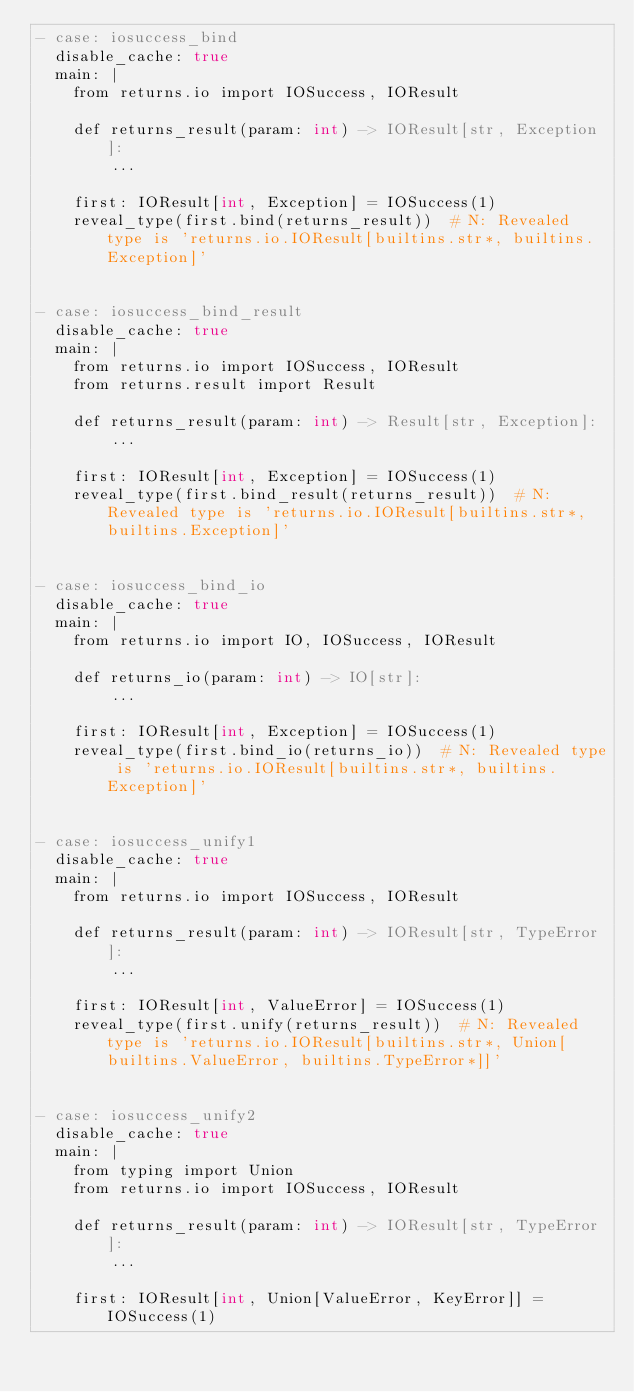Convert code to text. <code><loc_0><loc_0><loc_500><loc_500><_YAML_>- case: iosuccess_bind
  disable_cache: true
  main: |
    from returns.io import IOSuccess, IOResult

    def returns_result(param: int) -> IOResult[str, Exception]:
        ...

    first: IOResult[int, Exception] = IOSuccess(1)
    reveal_type(first.bind(returns_result))  # N: Revealed type is 'returns.io.IOResult[builtins.str*, builtins.Exception]'


- case: iosuccess_bind_result
  disable_cache: true
  main: |
    from returns.io import IOSuccess, IOResult
    from returns.result import Result

    def returns_result(param: int) -> Result[str, Exception]:
        ...

    first: IOResult[int, Exception] = IOSuccess(1)
    reveal_type(first.bind_result(returns_result))  # N: Revealed type is 'returns.io.IOResult[builtins.str*, builtins.Exception]'


- case: iosuccess_bind_io
  disable_cache: true
  main: |
    from returns.io import IO, IOSuccess, IOResult

    def returns_io(param: int) -> IO[str]:
        ...

    first: IOResult[int, Exception] = IOSuccess(1)
    reveal_type(first.bind_io(returns_io))  # N: Revealed type is 'returns.io.IOResult[builtins.str*, builtins.Exception]'


- case: iosuccess_unify1
  disable_cache: true
  main: |
    from returns.io import IOSuccess, IOResult

    def returns_result(param: int) -> IOResult[str, TypeError]:
        ...

    first: IOResult[int, ValueError] = IOSuccess(1)
    reveal_type(first.unify(returns_result))  # N: Revealed type is 'returns.io.IOResult[builtins.str*, Union[builtins.ValueError, builtins.TypeError*]]'


- case: iosuccess_unify2
  disable_cache: true
  main: |
    from typing import Union
    from returns.io import IOSuccess, IOResult

    def returns_result(param: int) -> IOResult[str, TypeError]:
        ...

    first: IOResult[int, Union[ValueError, KeyError]] = IOSuccess(1)</code> 